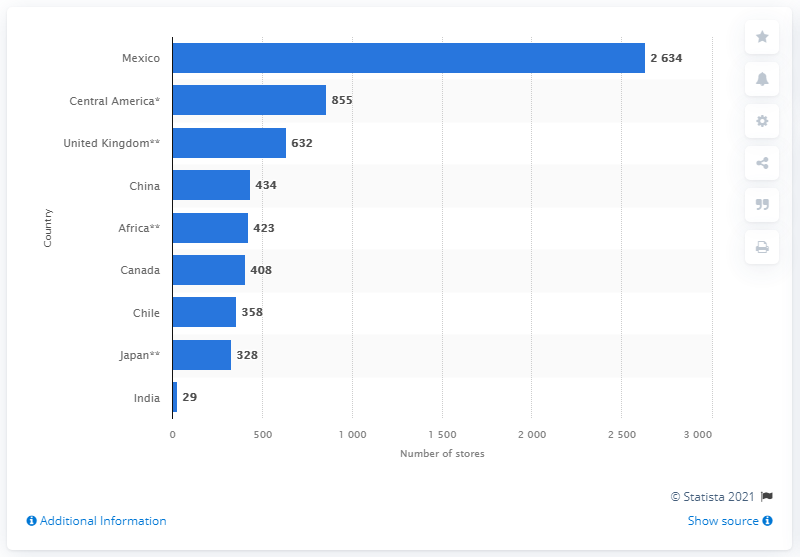Give some essential details in this illustration. As of December 31, 2021, Walmart International had 632 stores in the UK. 